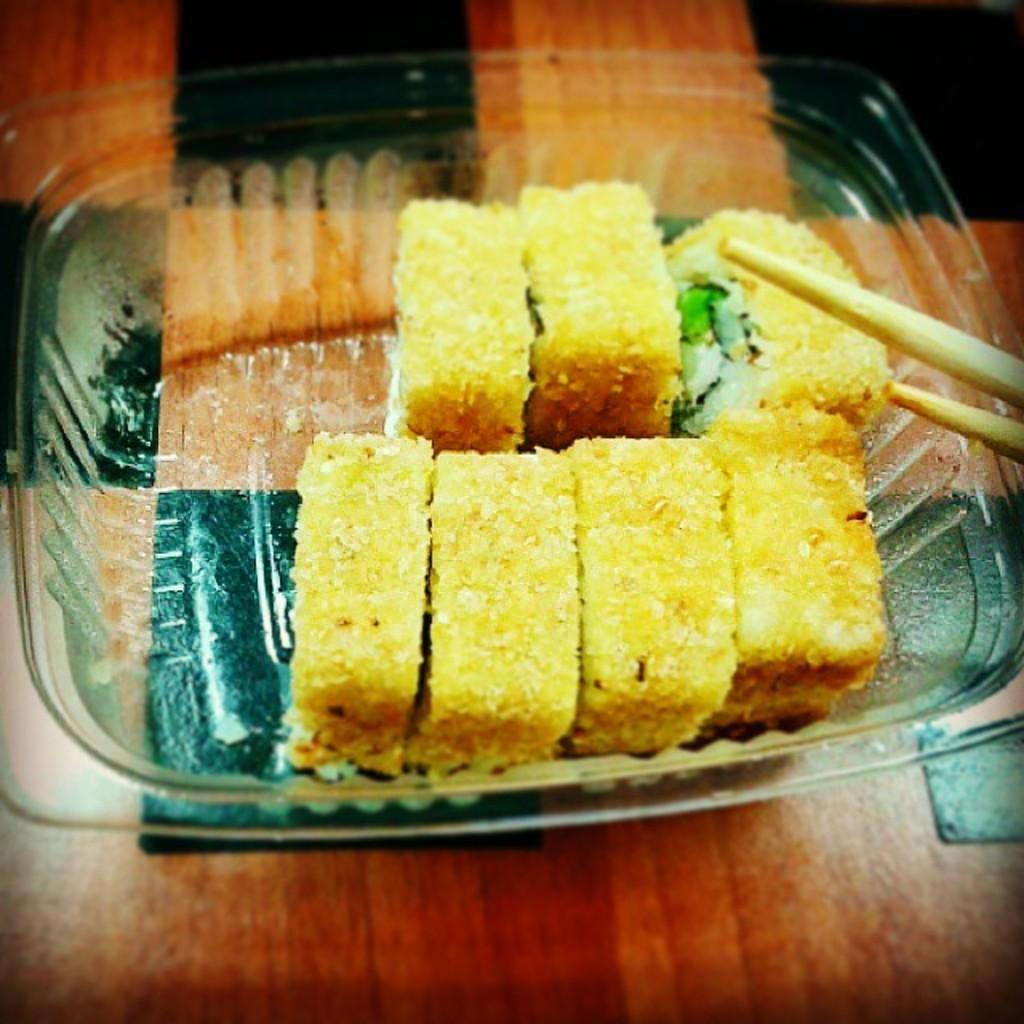What is in the bowl that is visible in the image? There is food in the bowl in the image. What utensil is present on the right side of the image? Chopsticks are present on the right side of the image. What type of surface is visible at the bottom of the image? There is a wooden surface at the bottom of the image. What type of hospital is visible in the image? There is no hospital present in the image; it features a bowl with food and chopsticks on a wooden surface. What type of harmony is depicted in the image? The image does not depict any harmony; it is a simple scene of a bowl with food and chopsticks on a wooden surface. 